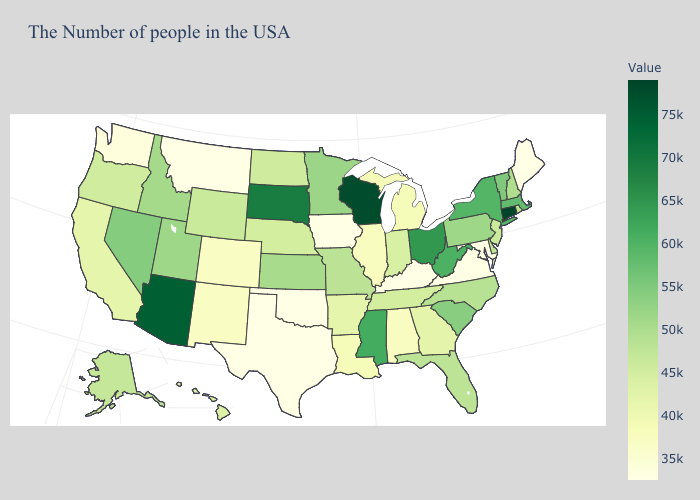Does the map have missing data?
Concise answer only. No. Which states hav the highest value in the West?
Concise answer only. Arizona. 